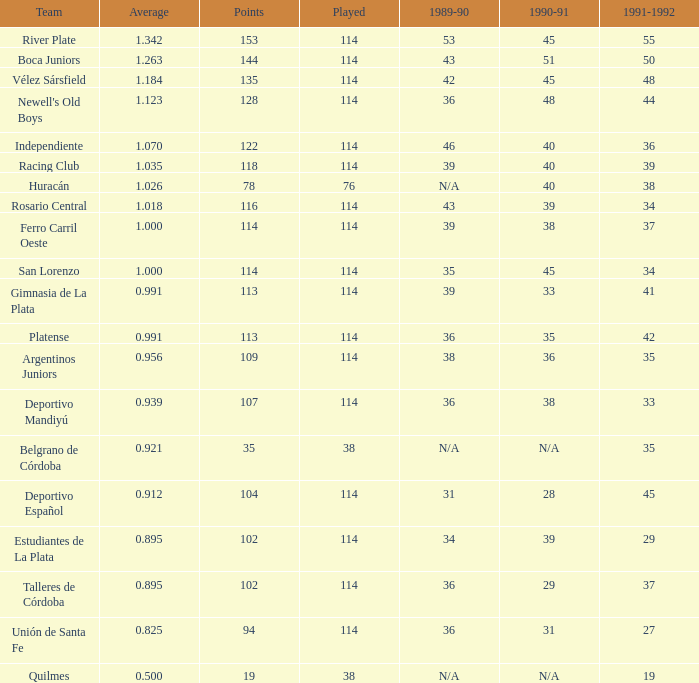In the 1989-90 season, for a talleres de córdoba team with an average of 36 and playing fewer than 114 games, what is the average? 0.0. 